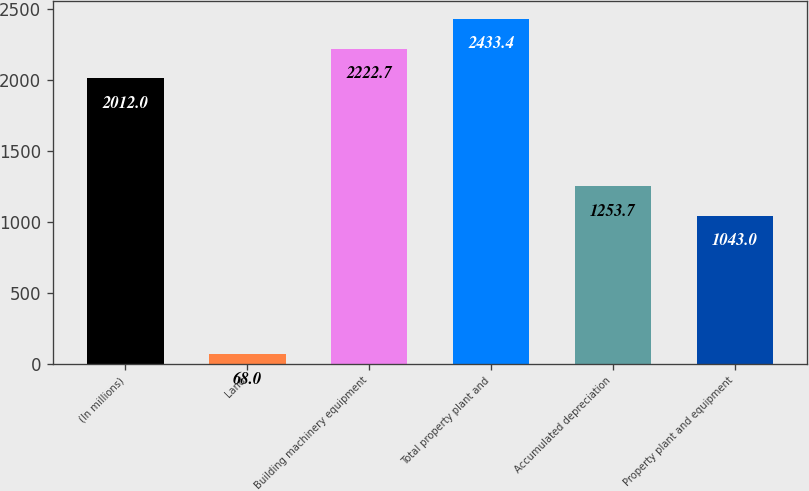Convert chart. <chart><loc_0><loc_0><loc_500><loc_500><bar_chart><fcel>(In millions)<fcel>Land<fcel>Building machinery equipment<fcel>Total property plant and<fcel>Accumulated depreciation<fcel>Property plant and equipment<nl><fcel>2012<fcel>68<fcel>2222.7<fcel>2433.4<fcel>1253.7<fcel>1043<nl></chart> 